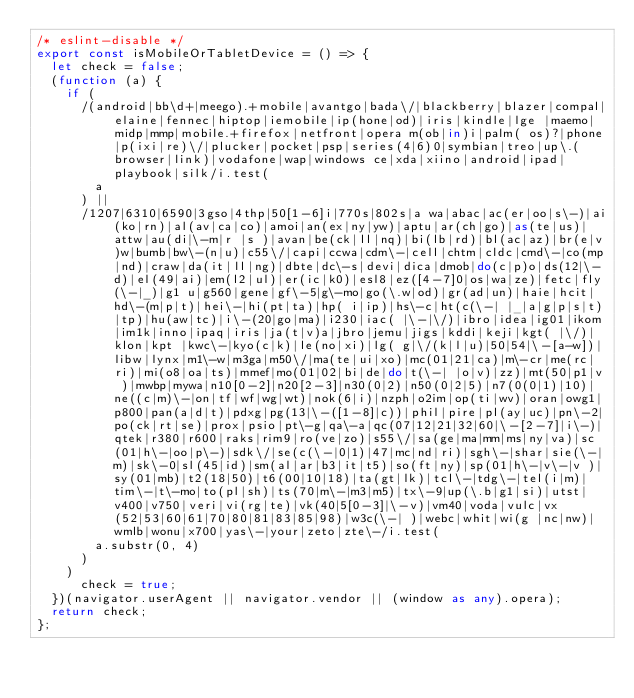Convert code to text. <code><loc_0><loc_0><loc_500><loc_500><_TypeScript_>/* eslint-disable */
export const isMobileOrTabletDevice = () => {
  let check = false;
  (function (a) {
    if (
      /(android|bb\d+|meego).+mobile|avantgo|bada\/|blackberry|blazer|compal|elaine|fennec|hiptop|iemobile|ip(hone|od)|iris|kindle|lge |maemo|midp|mmp|mobile.+firefox|netfront|opera m(ob|in)i|palm( os)?|phone|p(ixi|re)\/|plucker|pocket|psp|series(4|6)0|symbian|treo|up\.(browser|link)|vodafone|wap|windows ce|xda|xiino|android|ipad|playbook|silk/i.test(
        a
      ) ||
      /1207|6310|6590|3gso|4thp|50[1-6]i|770s|802s|a wa|abac|ac(er|oo|s\-)|ai(ko|rn)|al(av|ca|co)|amoi|an(ex|ny|yw)|aptu|ar(ch|go)|as(te|us)|attw|au(di|\-m|r |s )|avan|be(ck|ll|nq)|bi(lb|rd)|bl(ac|az)|br(e|v)w|bumb|bw\-(n|u)|c55\/|capi|ccwa|cdm\-|cell|chtm|cldc|cmd\-|co(mp|nd)|craw|da(it|ll|ng)|dbte|dc\-s|devi|dica|dmob|do(c|p)o|ds(12|\-d)|el(49|ai)|em(l2|ul)|er(ic|k0)|esl8|ez([4-7]0|os|wa|ze)|fetc|fly(\-|_)|g1 u|g560|gene|gf\-5|g\-mo|go(\.w|od)|gr(ad|un)|haie|hcit|hd\-(m|p|t)|hei\-|hi(pt|ta)|hp( i|ip)|hs\-c|ht(c(\-| |_|a|g|p|s|t)|tp)|hu(aw|tc)|i\-(20|go|ma)|i230|iac( |\-|\/)|ibro|idea|ig01|ikom|im1k|inno|ipaq|iris|ja(t|v)a|jbro|jemu|jigs|kddi|keji|kgt( |\/)|klon|kpt |kwc\-|kyo(c|k)|le(no|xi)|lg( g|\/(k|l|u)|50|54|\-[a-w])|libw|lynx|m1\-w|m3ga|m50\/|ma(te|ui|xo)|mc(01|21|ca)|m\-cr|me(rc|ri)|mi(o8|oa|ts)|mmef|mo(01|02|bi|de|do|t(\-| |o|v)|zz)|mt(50|p1|v )|mwbp|mywa|n10[0-2]|n20[2-3]|n30(0|2)|n50(0|2|5)|n7(0(0|1)|10)|ne((c|m)\-|on|tf|wf|wg|wt)|nok(6|i)|nzph|o2im|op(ti|wv)|oran|owg1|p800|pan(a|d|t)|pdxg|pg(13|\-([1-8]|c))|phil|pire|pl(ay|uc)|pn\-2|po(ck|rt|se)|prox|psio|pt\-g|qa\-a|qc(07|12|21|32|60|\-[2-7]|i\-)|qtek|r380|r600|raks|rim9|ro(ve|zo)|s55\/|sa(ge|ma|mm|ms|ny|va)|sc(01|h\-|oo|p\-)|sdk\/|se(c(\-|0|1)|47|mc|nd|ri)|sgh\-|shar|sie(\-|m)|sk\-0|sl(45|id)|sm(al|ar|b3|it|t5)|so(ft|ny)|sp(01|h\-|v\-|v )|sy(01|mb)|t2(18|50)|t6(00|10|18)|ta(gt|lk)|tcl\-|tdg\-|tel(i|m)|tim\-|t\-mo|to(pl|sh)|ts(70|m\-|m3|m5)|tx\-9|up(\.b|g1|si)|utst|v400|v750|veri|vi(rg|te)|vk(40|5[0-3]|\-v)|vm40|voda|vulc|vx(52|53|60|61|70|80|81|83|85|98)|w3c(\-| )|webc|whit|wi(g |nc|nw)|wmlb|wonu|x700|yas\-|your|zeto|zte\-/i.test(
        a.substr(0, 4)
      )
    )
      check = true;
  })(navigator.userAgent || navigator.vendor || (window as any).opera);
  return check;
};
</code> 